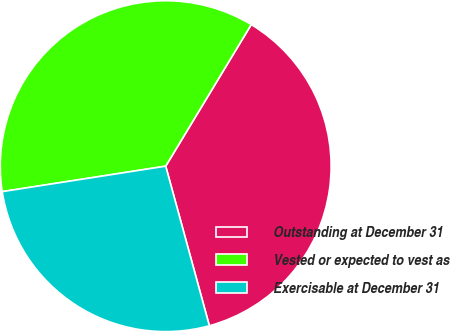Convert chart. <chart><loc_0><loc_0><loc_500><loc_500><pie_chart><fcel>Outstanding at December 31<fcel>Vested or expected to vest as<fcel>Exercisable at December 31<nl><fcel>37.1%<fcel>36.11%<fcel>26.79%<nl></chart> 